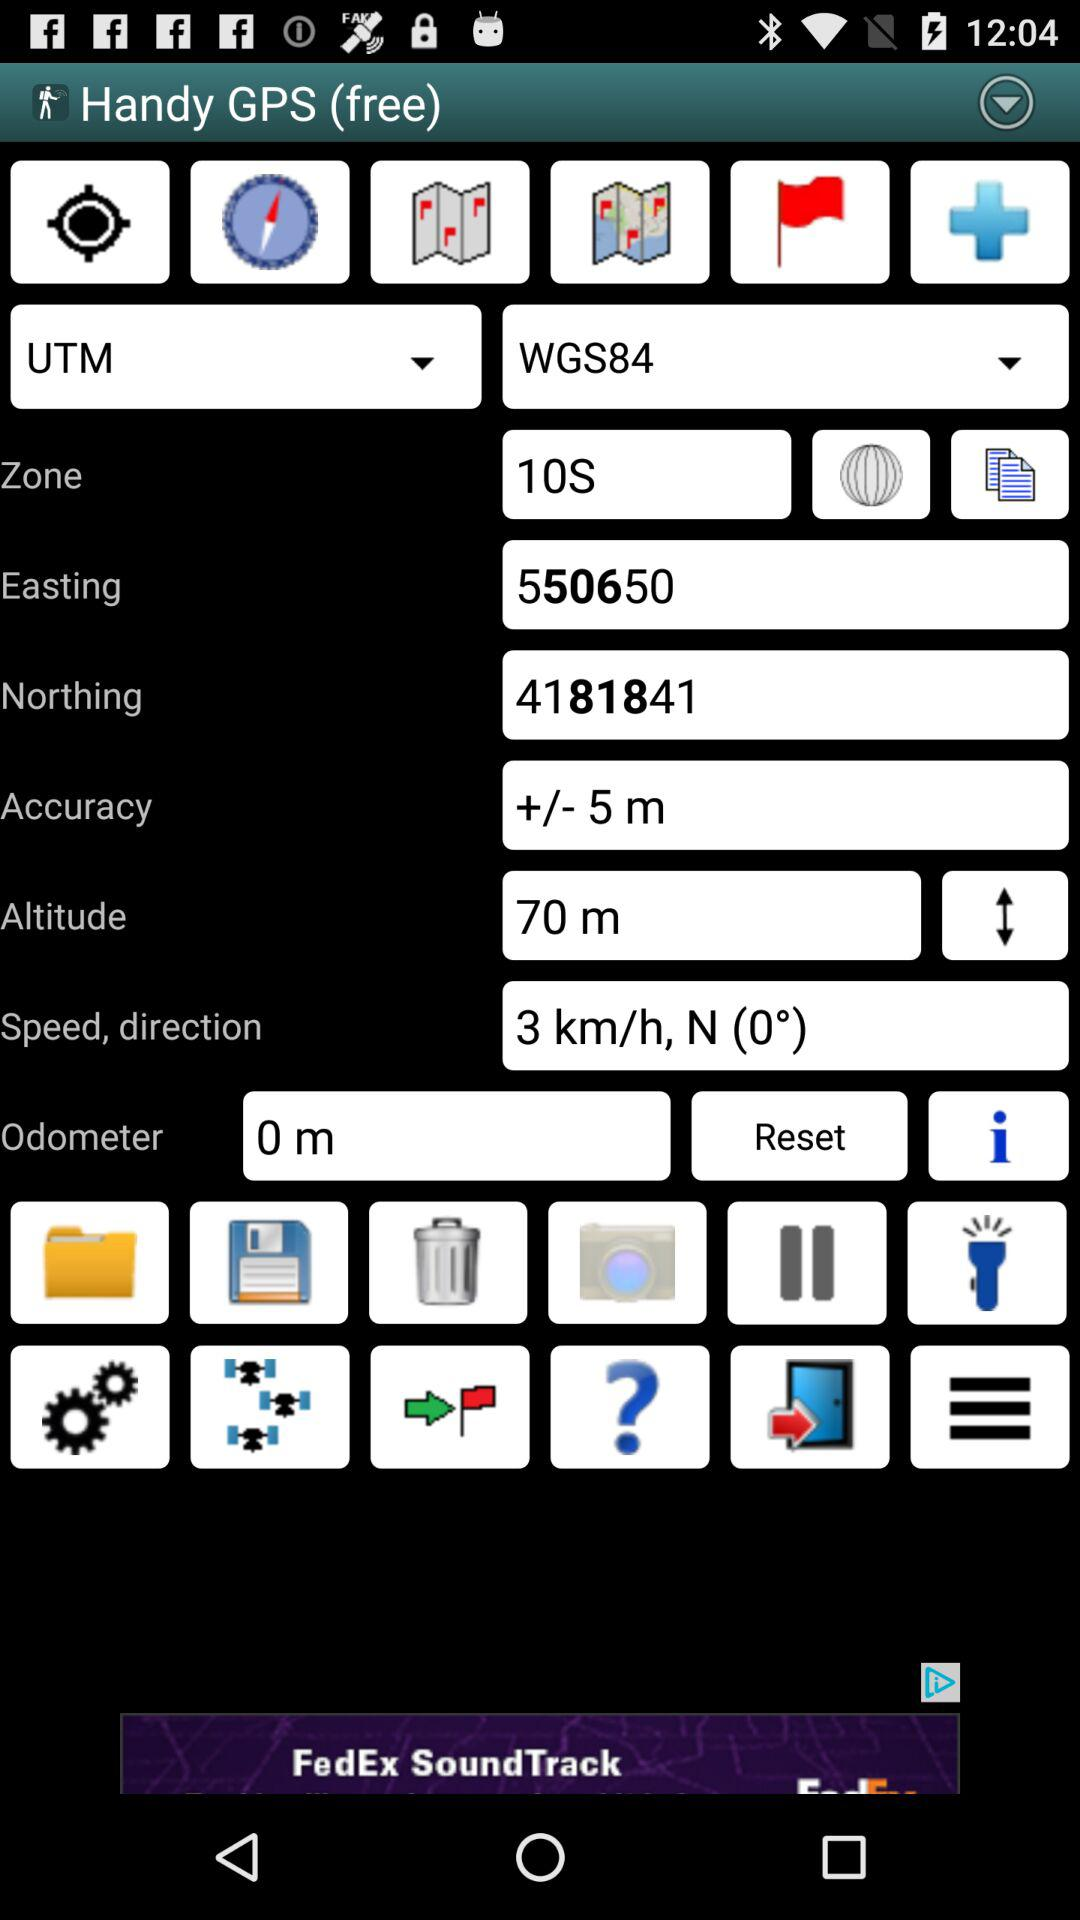What are the two coordinate systems available?
Answer the question using a single word or phrase. UTM and WGS84 